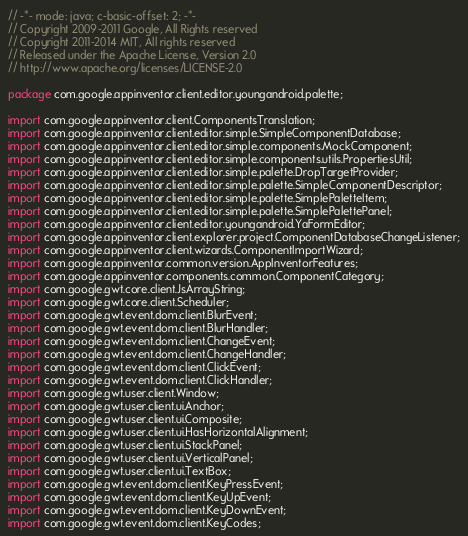Convert code to text. <code><loc_0><loc_0><loc_500><loc_500><_Java_>// -*- mode: java; c-basic-offset: 2; -*-
// Copyright 2009-2011 Google, All Rights reserved
// Copyright 2011-2014 MIT, All rights reserved
// Released under the Apache License, Version 2.0
// http://www.apache.org/licenses/LICENSE-2.0

package com.google.appinventor.client.editor.youngandroid.palette;

import com.google.appinventor.client.ComponentsTranslation;
import com.google.appinventor.client.editor.simple.SimpleComponentDatabase;
import com.google.appinventor.client.editor.simple.components.MockComponent;
import com.google.appinventor.client.editor.simple.components.utils.PropertiesUtil;
import com.google.appinventor.client.editor.simple.palette.DropTargetProvider;
import com.google.appinventor.client.editor.simple.palette.SimpleComponentDescriptor;
import com.google.appinventor.client.editor.simple.palette.SimplePaletteItem;
import com.google.appinventor.client.editor.simple.palette.SimplePalettePanel;
import com.google.appinventor.client.editor.youngandroid.YaFormEditor;
import com.google.appinventor.client.explorer.project.ComponentDatabaseChangeListener;
import com.google.appinventor.client.wizards.ComponentImportWizard;
import com.google.appinventor.common.version.AppInventorFeatures;
import com.google.appinventor.components.common.ComponentCategory;
import com.google.gwt.core.client.JsArrayString;
import com.google.gwt.core.client.Scheduler;
import com.google.gwt.event.dom.client.BlurEvent;
import com.google.gwt.event.dom.client.BlurHandler;
import com.google.gwt.event.dom.client.ChangeEvent;
import com.google.gwt.event.dom.client.ChangeHandler;
import com.google.gwt.event.dom.client.ClickEvent;
import com.google.gwt.event.dom.client.ClickHandler;
import com.google.gwt.user.client.Window;
import com.google.gwt.user.client.ui.Anchor;
import com.google.gwt.user.client.ui.Composite;
import com.google.gwt.user.client.ui.HasHorizontalAlignment;
import com.google.gwt.user.client.ui.StackPanel;
import com.google.gwt.user.client.ui.VerticalPanel;
import com.google.gwt.user.client.ui.TextBox;
import com.google.gwt.event.dom.client.KeyPressEvent;
import com.google.gwt.event.dom.client.KeyUpEvent;
import com.google.gwt.event.dom.client.KeyDownEvent;
import com.google.gwt.event.dom.client.KeyCodes;</code> 